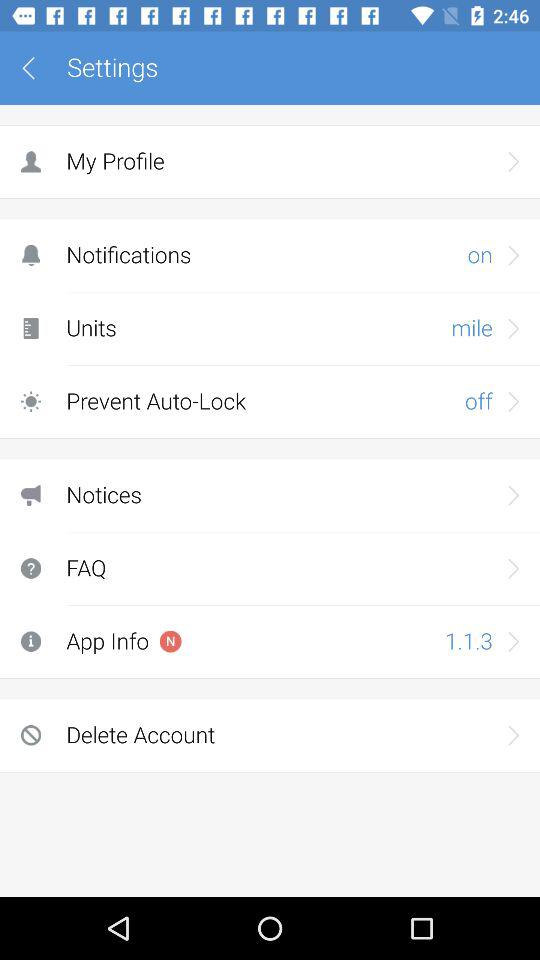What is the setting for notifications? The setting for notifications is "on". 